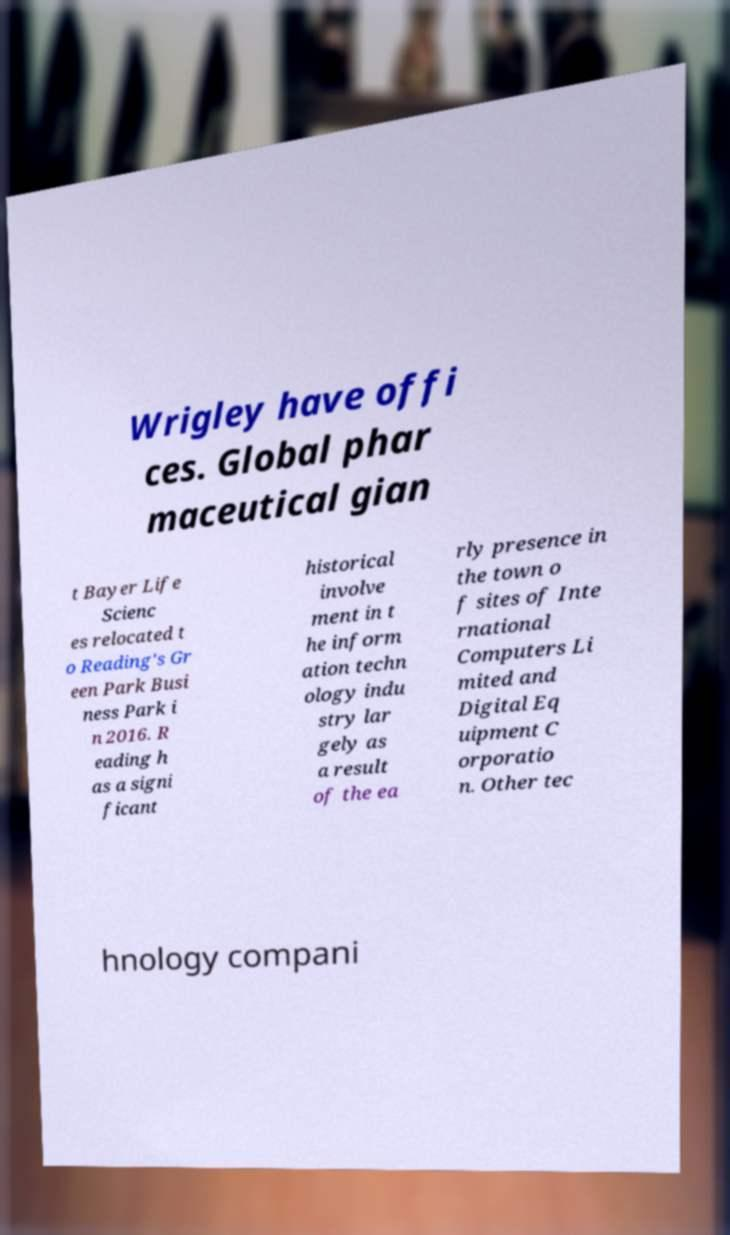Please read and relay the text visible in this image. What does it say? Wrigley have offi ces. Global phar maceutical gian t Bayer Life Scienc es relocated t o Reading's Gr een Park Busi ness Park i n 2016. R eading h as a signi ficant historical involve ment in t he inform ation techn ology indu stry lar gely as a result of the ea rly presence in the town o f sites of Inte rnational Computers Li mited and Digital Eq uipment C orporatio n. Other tec hnology compani 